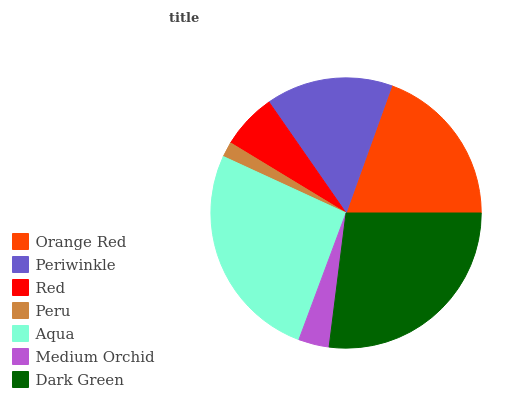Is Peru the minimum?
Answer yes or no. Yes. Is Dark Green the maximum?
Answer yes or no. Yes. Is Periwinkle the minimum?
Answer yes or no. No. Is Periwinkle the maximum?
Answer yes or no. No. Is Orange Red greater than Periwinkle?
Answer yes or no. Yes. Is Periwinkle less than Orange Red?
Answer yes or no. Yes. Is Periwinkle greater than Orange Red?
Answer yes or no. No. Is Orange Red less than Periwinkle?
Answer yes or no. No. Is Periwinkle the high median?
Answer yes or no. Yes. Is Periwinkle the low median?
Answer yes or no. Yes. Is Medium Orchid the high median?
Answer yes or no. No. Is Medium Orchid the low median?
Answer yes or no. No. 